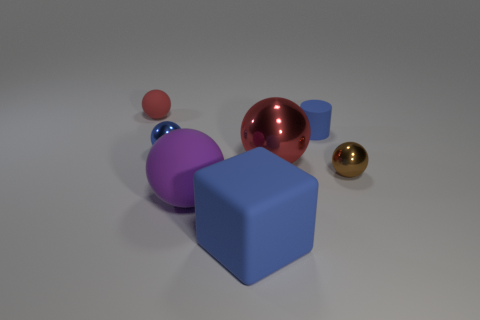Are there any other things that are the same shape as the big blue matte thing?
Keep it short and to the point. No. How many things are on the left side of the large red shiny sphere and behind the blue ball?
Offer a very short reply. 1. Are there any purple spheres that have the same material as the big blue cube?
Offer a very short reply. Yes. There is a rubber cube that is the same color as the tiny cylinder; what is its size?
Ensure brevity in your answer.  Large. How many blocks are blue metal things or tiny shiny objects?
Keep it short and to the point. 0. The matte cylinder has what size?
Make the answer very short. Small. There is a large shiny thing; what number of red matte balls are in front of it?
Keep it short and to the point. 0. What is the size of the brown ball that is in front of the rubber sphere that is behind the purple rubber thing?
Provide a short and direct response. Small. There is a tiny blue thing that is left of the big purple rubber object; is it the same shape as the red thing that is in front of the blue ball?
Your answer should be very brief. Yes. The tiny metal object that is on the left side of the tiny metal thing in front of the large red metal object is what shape?
Offer a terse response. Sphere. 